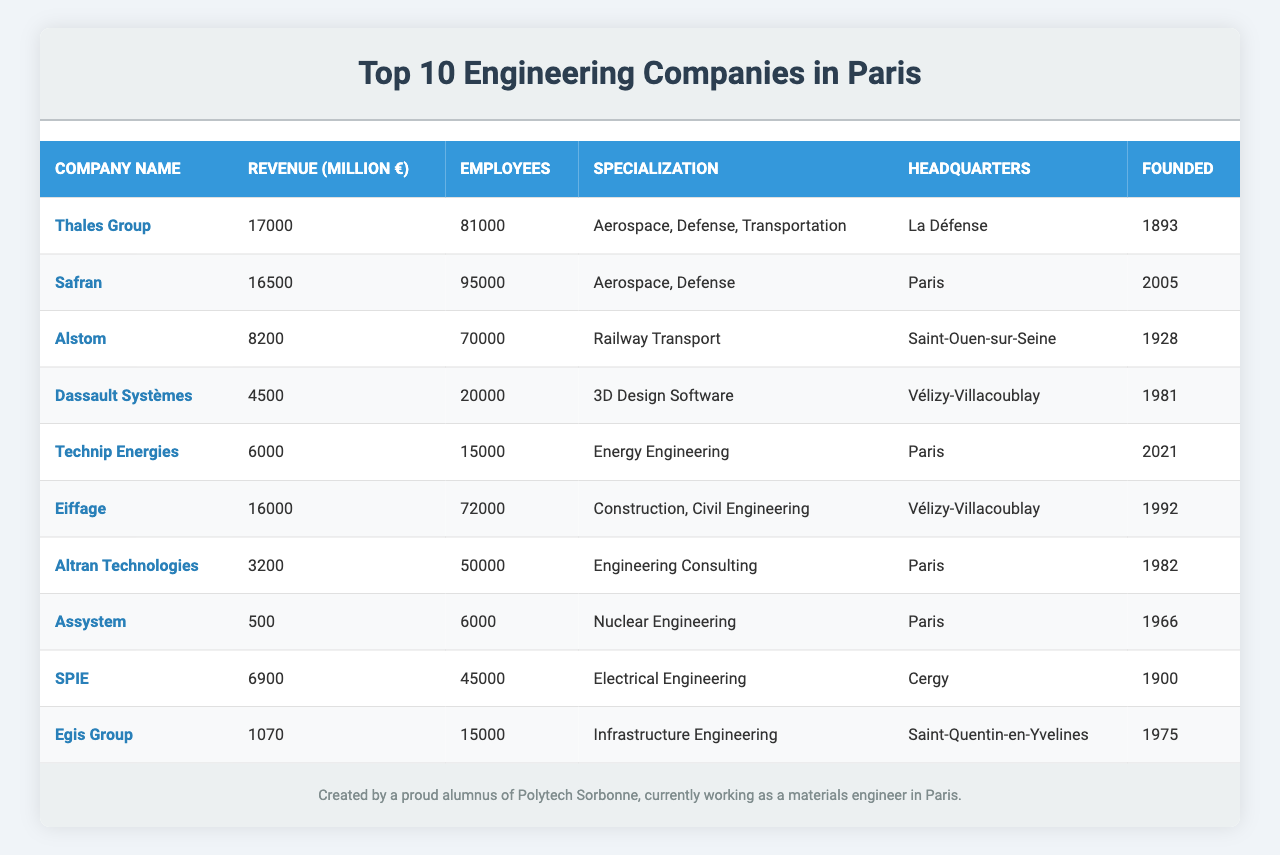What is the revenue of Thales Group? The table shows that Thales Group has a revenue of 17,000 million euros.
Answer: 17,000 million euros Which company has the highest employee count? According to the table, Safran has the highest employee count at 95,000.
Answer: Safran What is the total revenue of the top three companies? Adding the revenue of the top three companies (Thales Group, Safran, and Eiffage): 17,000 + 16,500 + 16,000 = 49,500 million euros.
Answer: 49,500 million euros How many employees does Dassault Systèmes have? The table indicates that Dassault Systèmes has 20,000 employees.
Answer: 20,000 employees Is Altran Technologies specialized in Civil Engineering? The table shows that Altran Technologies specializes in Engineering Consulting, not Civil Engineering, so this statement is false.
Answer: No What percentage of the total employee count do Eiffage and Technip Energies have combined? Eiffage has 72,000 employees and Technip Energies has 15,000; their total is 72,000 + 15,000 = 87,000. The total number of employees across all companies is 450,000. Thus, (87,000 / 450,000) * 100 = 19.33%.
Answer: 19.33% Which company was founded most recently? The table shows that Technip Energies was founded in 2021, making it the most recently founded company.
Answer: Technip Energies What is the median revenue of the companies listed? The revenues sorted in ascending order are: 500, 1,070, 3,200, 4,500, 6,000, 6,900, 8,200, 16,000, 16,500, 17,000. The median, being the average of the 5th and 6th values (6,000 and 6,900), is (6,000 + 6,900) / 2 = 6,450 million euros.
Answer: 6,450 million euros Which specialization has the least revenue? Assystem specializes in Nuclear Engineering and has the least revenue of 500 million euros as per the table.
Answer: Nuclear Engineering Are there more companies headquartered in Paris than in La Défense? The table shows four companies based in Paris (Safran, Technip Energies, Altran Technologies, Assystem) and one in La Défense (Thales Group), so there are indeed more in Paris.
Answer: Yes 